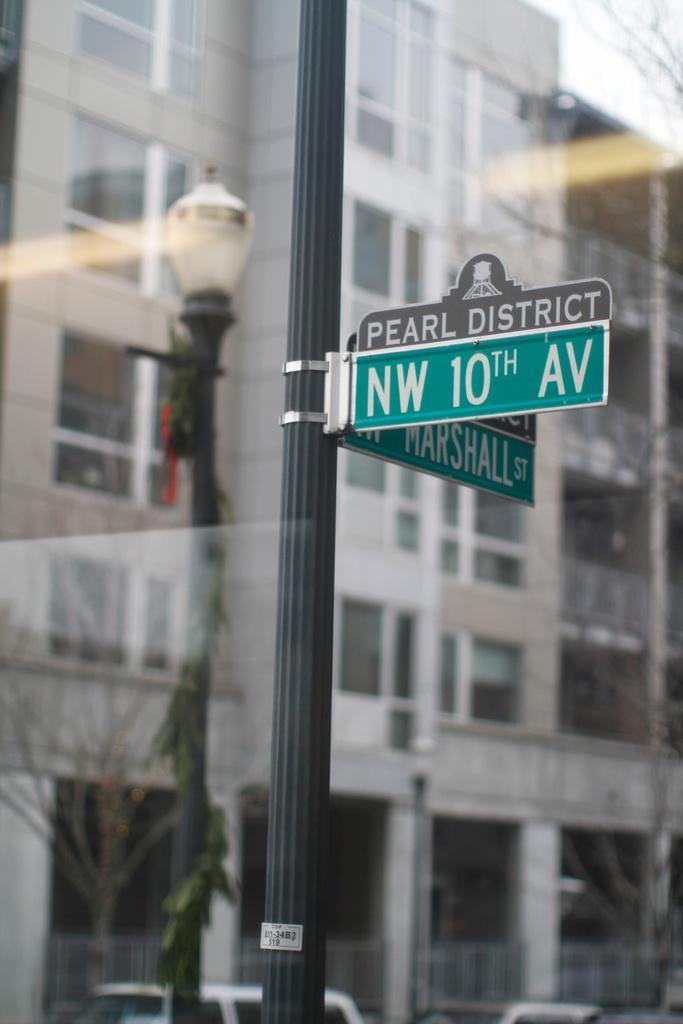How would you summarize this image in a sentence or two? In this picture there is a sign pole in the center of the image and there are cars at the bottom side of the image and there are buildings and a lamp pole in the background area of the image. 